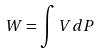<formula> <loc_0><loc_0><loc_500><loc_500>W = \int V d P</formula> 